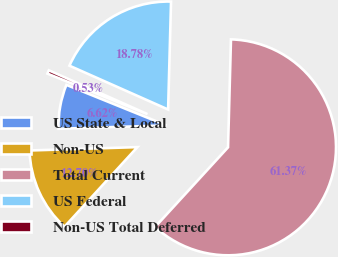<chart> <loc_0><loc_0><loc_500><loc_500><pie_chart><fcel>US State & Local<fcel>Non-US<fcel>Total Current<fcel>US Federal<fcel>Non-US Total Deferred<nl><fcel>6.62%<fcel>12.7%<fcel>61.37%<fcel>18.78%<fcel>0.53%<nl></chart> 